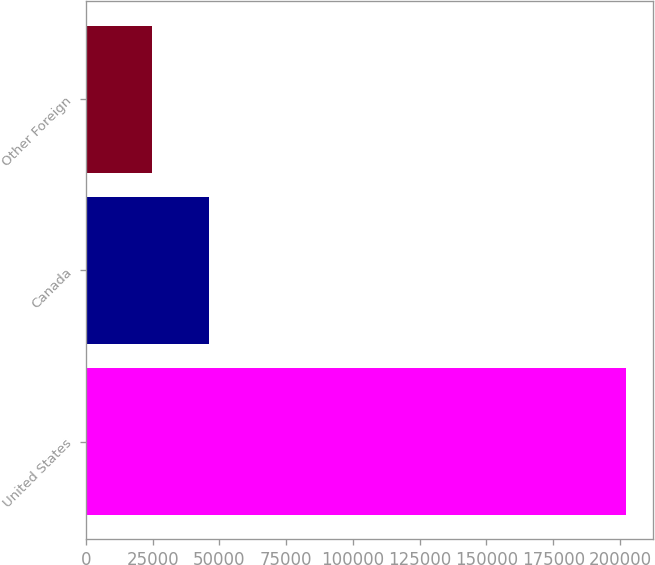<chart> <loc_0><loc_0><loc_500><loc_500><bar_chart><fcel>United States<fcel>Canada<fcel>Other Foreign<nl><fcel>202067<fcel>46191<fcel>24885<nl></chart> 